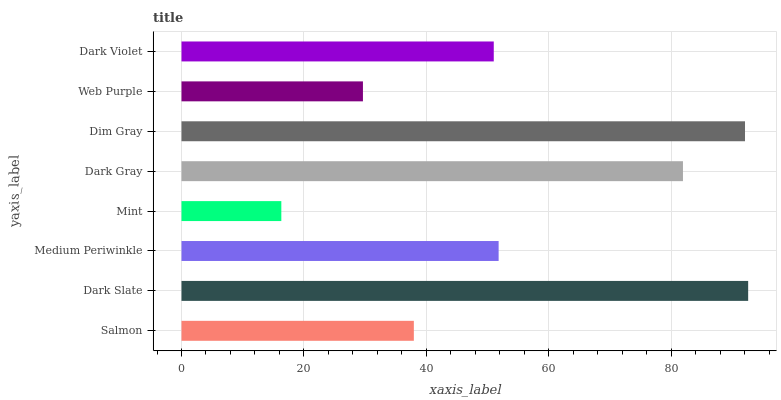Is Mint the minimum?
Answer yes or no. Yes. Is Dark Slate the maximum?
Answer yes or no. Yes. Is Medium Periwinkle the minimum?
Answer yes or no. No. Is Medium Periwinkle the maximum?
Answer yes or no. No. Is Dark Slate greater than Medium Periwinkle?
Answer yes or no. Yes. Is Medium Periwinkle less than Dark Slate?
Answer yes or no. Yes. Is Medium Periwinkle greater than Dark Slate?
Answer yes or no. No. Is Dark Slate less than Medium Periwinkle?
Answer yes or no. No. Is Medium Periwinkle the high median?
Answer yes or no. Yes. Is Dark Violet the low median?
Answer yes or no. Yes. Is Dark Gray the high median?
Answer yes or no. No. Is Dim Gray the low median?
Answer yes or no. No. 